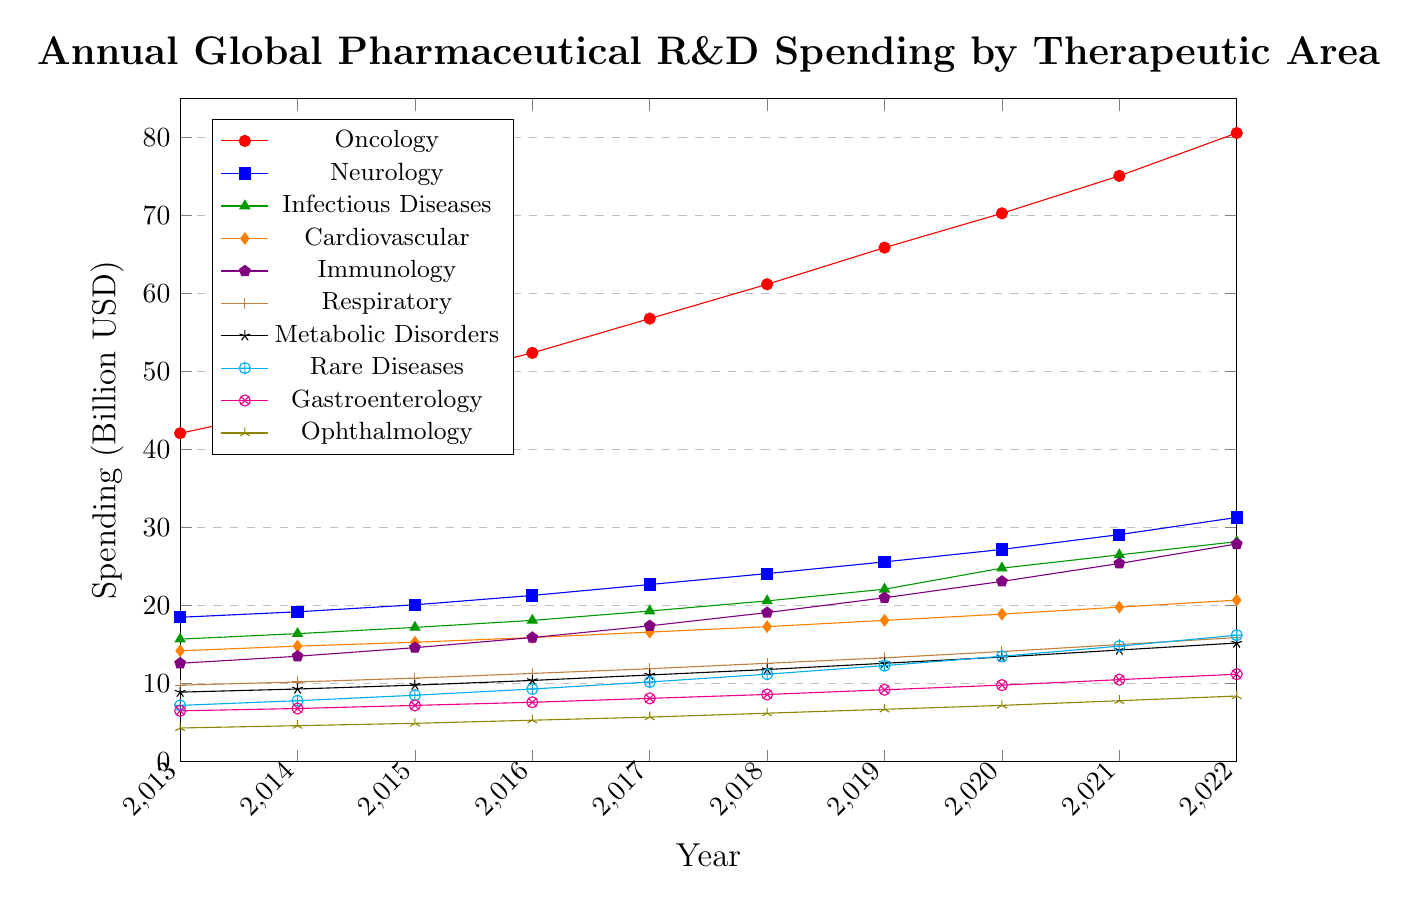What is the therapeutic area with the highest R&D spending in 2022? By observing the figure, Oncology has the highest position on the y-axis in 2022.
Answer: Oncology Which therapeutic area had the smallest increase in R&D spending from 2013 to 2022? By comparing the difference in y-values from 2013 to 2022 for each therapeutic area, Ophthalmology increased from 4.3 to 8.4, representing the smallest increase.
Answer: Ophthalmology How much has R&D spending on Neurology increased from 2013 to 2022? The spending on Neurology in 2013 was 18.5 and in 2022 it was 31.3. The increase is given by 31.3 - 18.5 = 12.8 billion USD.
Answer: 12.8 billion USD Between which two consecutive years did Infectious Diseases see the greatest increase in R&D spending? By looking at the line representing Infectious Diseases, the greatest slope occurs between 2019 and 2020, going from 22.1 to 24.8 billion USD.
Answer: 2019 and 2020 Which therapeutic area had a consistent annual increase in R&D spending throughout the decade? Oncology shows a steady and consistent increase in R&D spending every year from 2013 to 2022 without any fluctuations.
Answer: Oncology Compare the R&D spending on Immunology and Cardiovascular in 2018. Which was higher and by how much? In 2018, Immunology had an R&D spending of 19.1 billion USD while Cardiovascular had 17.3 billion USD, so Immunology was higher by 19.1 - 17.3 = 1.8 billion USD.
Answer: Immunology by 1.8 billion USD What is the average annual R&D spending on Metabolic Disorders from 2013 to 2022? Sum the values for each year and then divide by the number of years: (8.9 + 9.3 + 9.8 + 10.4 + 11.1 + 11.8 + 12.6 + 13.4 + 14.3 + 15.2) / 10 = 11.28 billion USD.
Answer: 11.28 billion USD Which therapeutic areas had an R&D spending of over 20 billion USD in 2022? From the figure, Oncology, Neurology, Infectious Diseases, Cardiovascular, and Immunology all have R&D spending over 20 billion USD in 2022.
Answer: Oncology, Neurology, Infectious Diseases, Cardiovascular, Immunology What was the R&D spending on Respiratory in 2016 compared to Metabolic Disorders in the same year? In 2016, Respiratory had an R&D spending of 11.3 billion USD, and Metabolic Disorders had 10.4 billion USD, so Respiratory was higher.
Answer: Respiratory was higher Which therapeutic area shows the most drastic growth trend visually? Visually, Oncology's line is the steepest and highest, indicating the most significant growth trend over the decade.
Answer: Oncology 